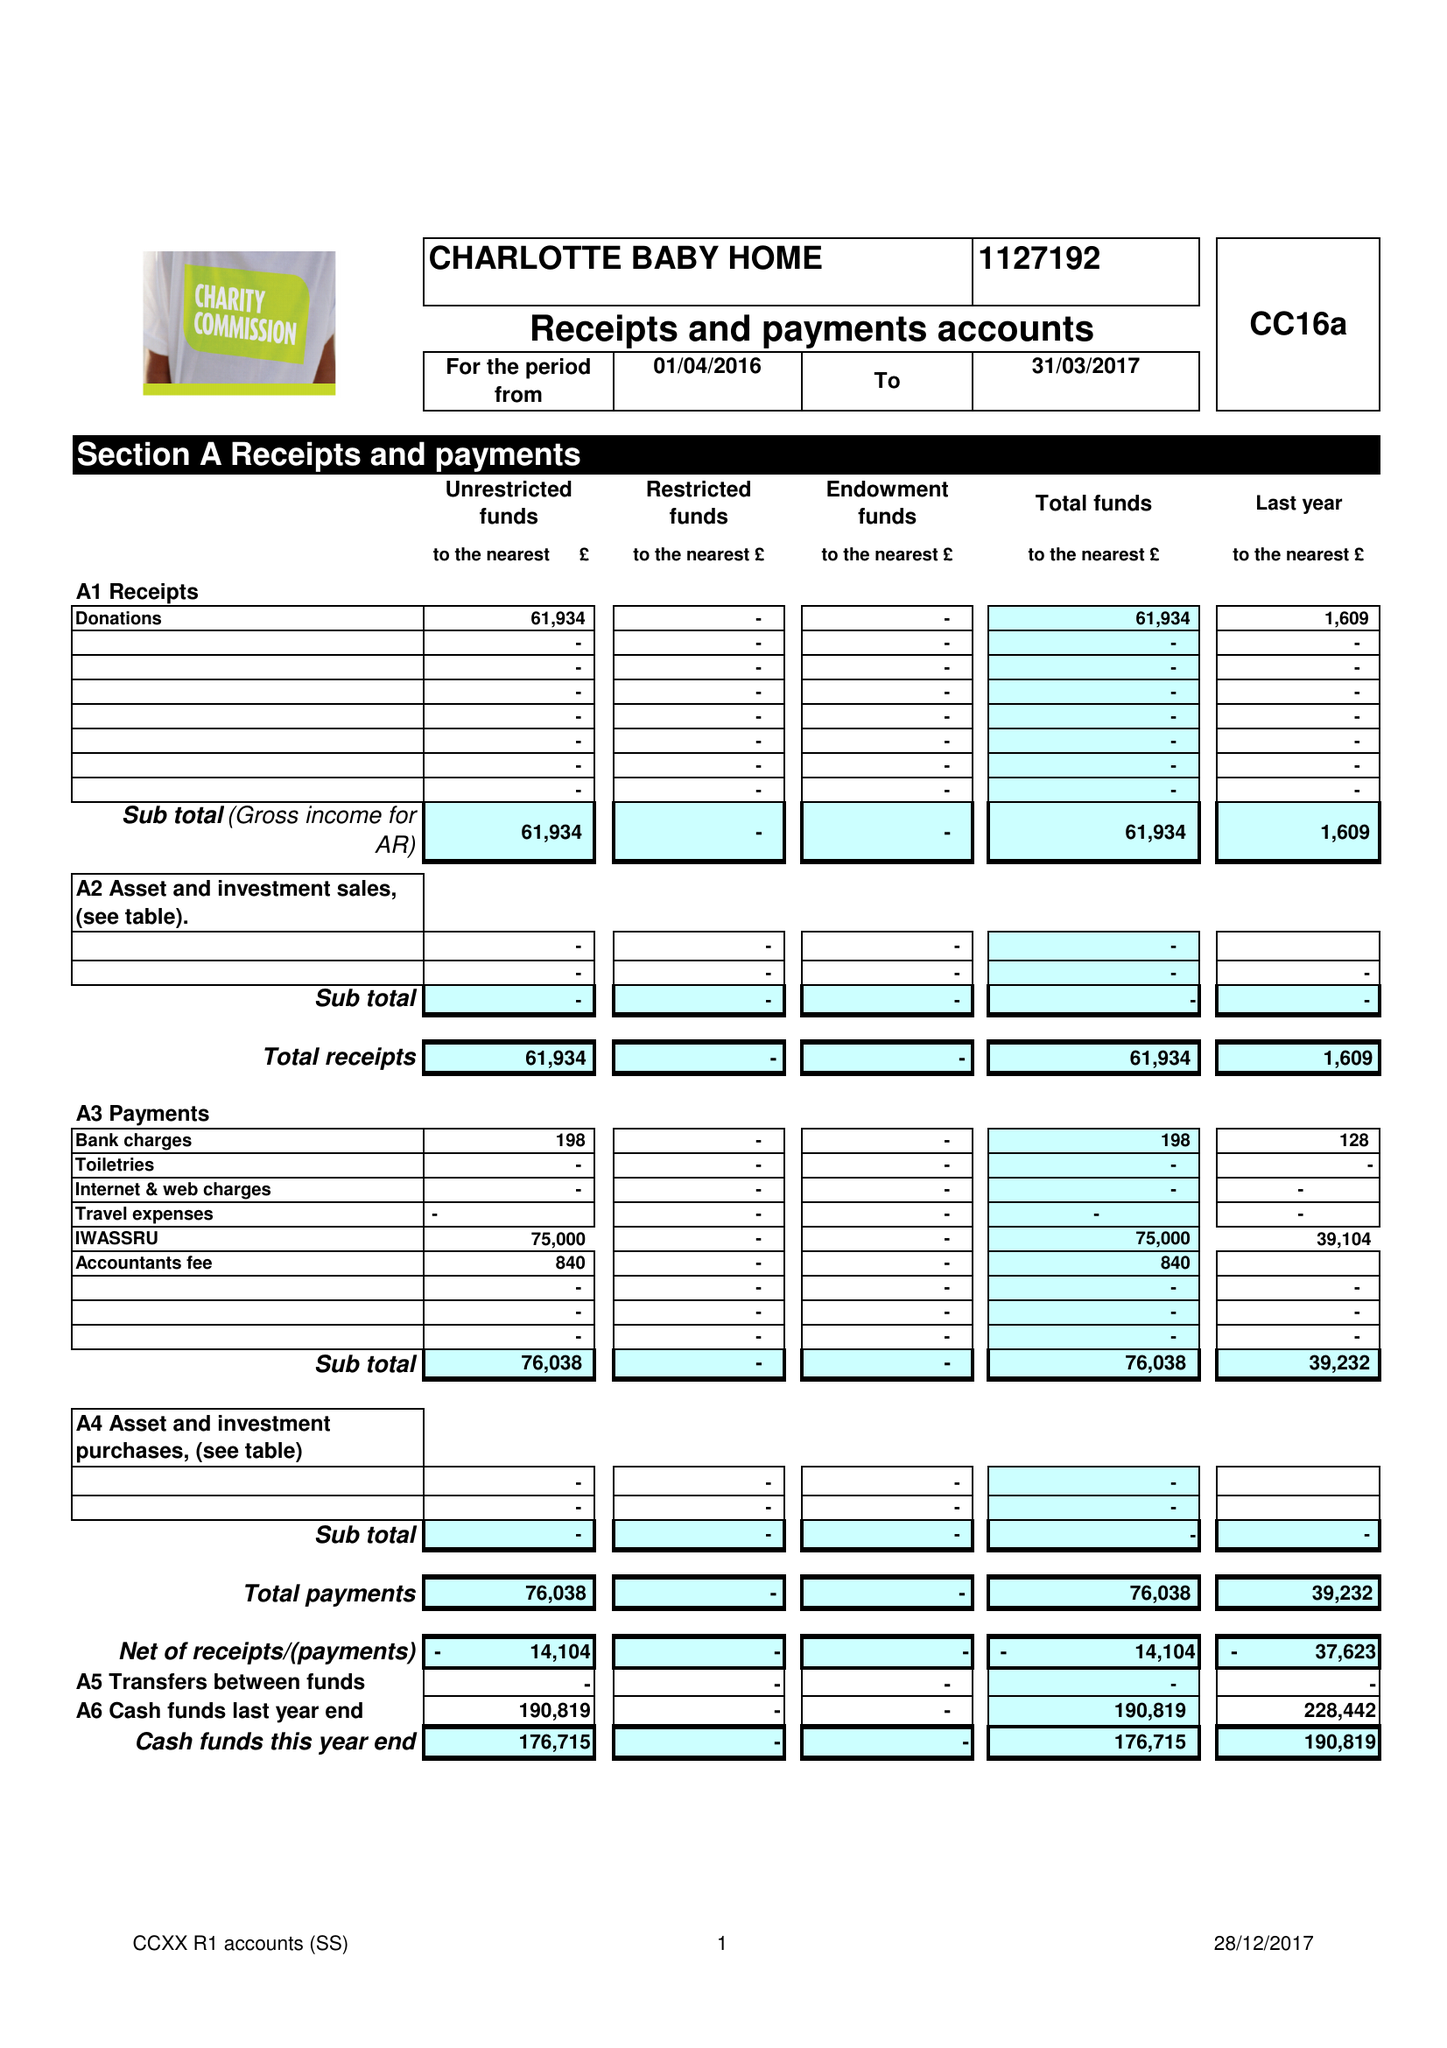What is the value for the report_date?
Answer the question using a single word or phrase. 2017-03-31 